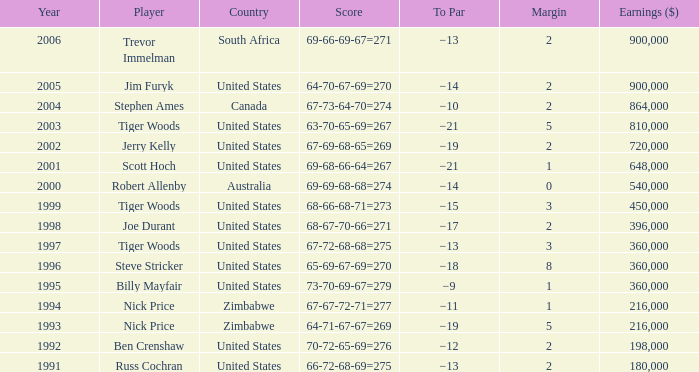Which Margin has a Country of united states, and a Score of 63-70-65-69=267? 5.0. 